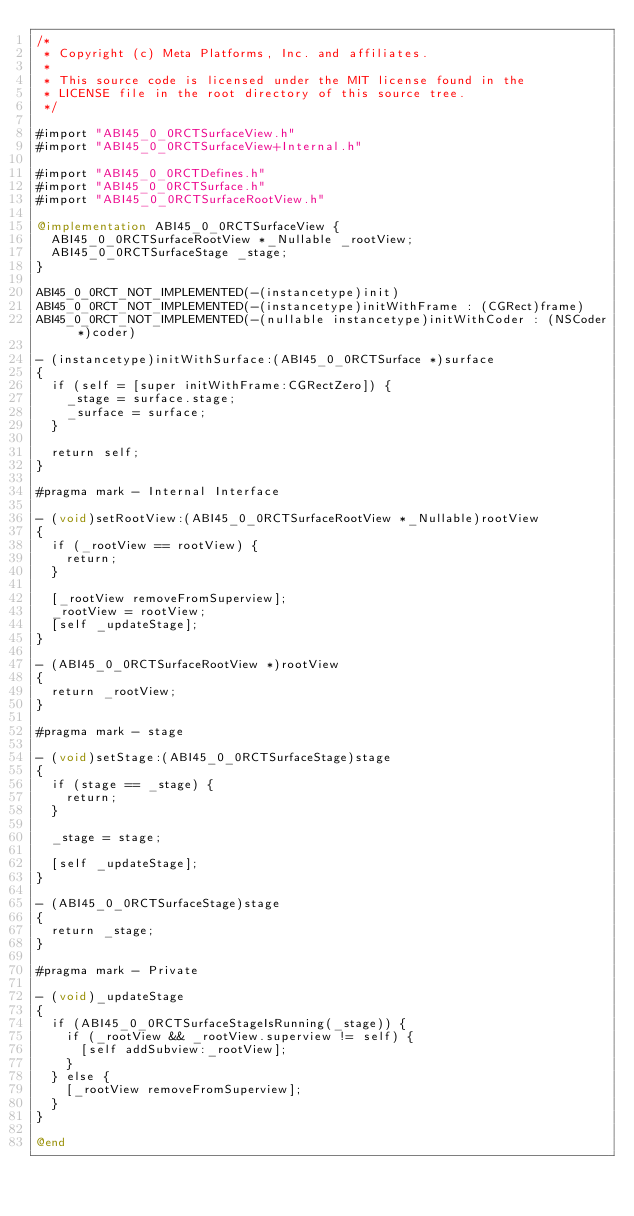<code> <loc_0><loc_0><loc_500><loc_500><_ObjectiveC_>/*
 * Copyright (c) Meta Platforms, Inc. and affiliates.
 *
 * This source code is licensed under the MIT license found in the
 * LICENSE file in the root directory of this source tree.
 */

#import "ABI45_0_0RCTSurfaceView.h"
#import "ABI45_0_0RCTSurfaceView+Internal.h"

#import "ABI45_0_0RCTDefines.h"
#import "ABI45_0_0RCTSurface.h"
#import "ABI45_0_0RCTSurfaceRootView.h"

@implementation ABI45_0_0RCTSurfaceView {
  ABI45_0_0RCTSurfaceRootView *_Nullable _rootView;
  ABI45_0_0RCTSurfaceStage _stage;
}

ABI45_0_0RCT_NOT_IMPLEMENTED(-(instancetype)init)
ABI45_0_0RCT_NOT_IMPLEMENTED(-(instancetype)initWithFrame : (CGRect)frame)
ABI45_0_0RCT_NOT_IMPLEMENTED(-(nullable instancetype)initWithCoder : (NSCoder *)coder)

- (instancetype)initWithSurface:(ABI45_0_0RCTSurface *)surface
{
  if (self = [super initWithFrame:CGRectZero]) {
    _stage = surface.stage;
    _surface = surface;
  }

  return self;
}

#pragma mark - Internal Interface

- (void)setRootView:(ABI45_0_0RCTSurfaceRootView *_Nullable)rootView
{
  if (_rootView == rootView) {
    return;
  }

  [_rootView removeFromSuperview];
  _rootView = rootView;
  [self _updateStage];
}

- (ABI45_0_0RCTSurfaceRootView *)rootView
{
  return _rootView;
}

#pragma mark - stage

- (void)setStage:(ABI45_0_0RCTSurfaceStage)stage
{
  if (stage == _stage) {
    return;
  }

  _stage = stage;

  [self _updateStage];
}

- (ABI45_0_0RCTSurfaceStage)stage
{
  return _stage;
}

#pragma mark - Private

- (void)_updateStage
{
  if (ABI45_0_0RCTSurfaceStageIsRunning(_stage)) {
    if (_rootView && _rootView.superview != self) {
      [self addSubview:_rootView];
    }
  } else {
    [_rootView removeFromSuperview];
  }
}

@end
</code> 